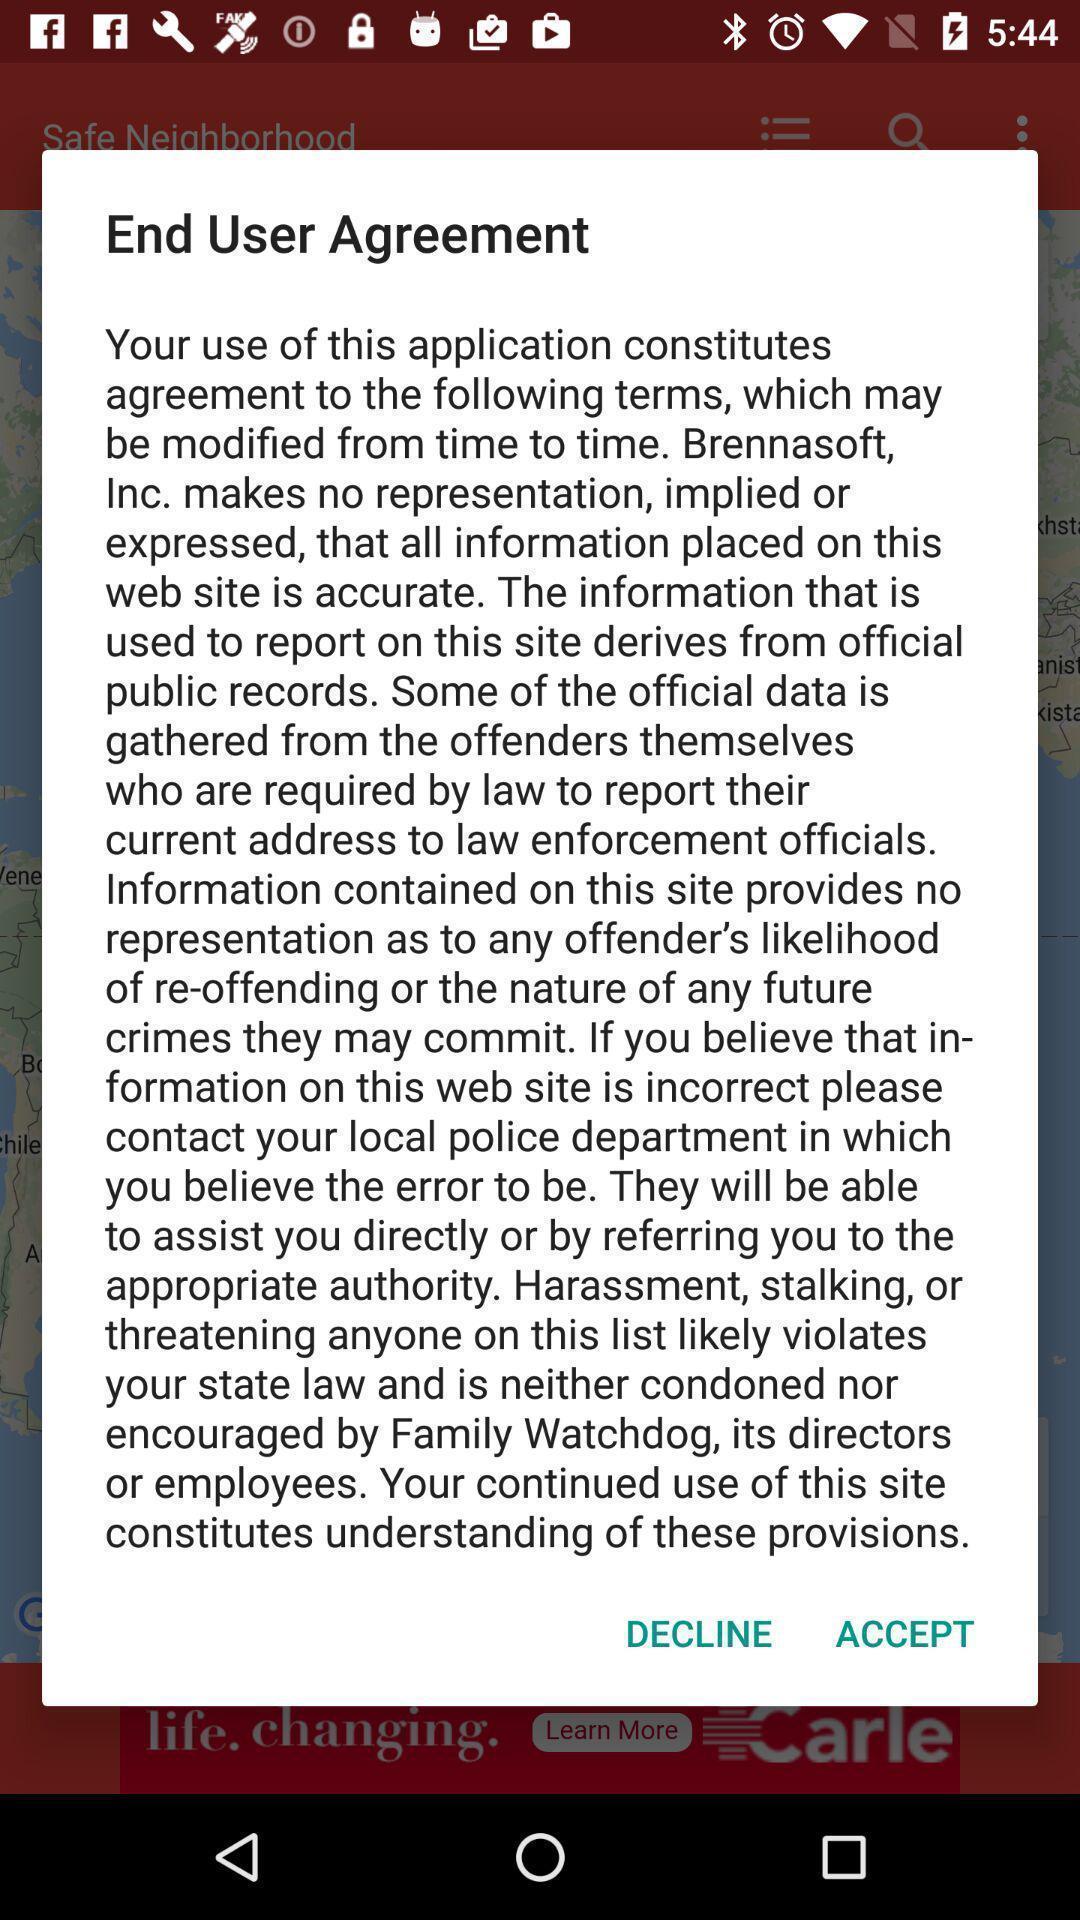Give me a summary of this screen capture. Popup showing end user agreement screen. 